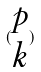Convert formula to latex. <formula><loc_0><loc_0><loc_500><loc_500>( \begin{matrix} p \\ k \end{matrix} )</formula> 